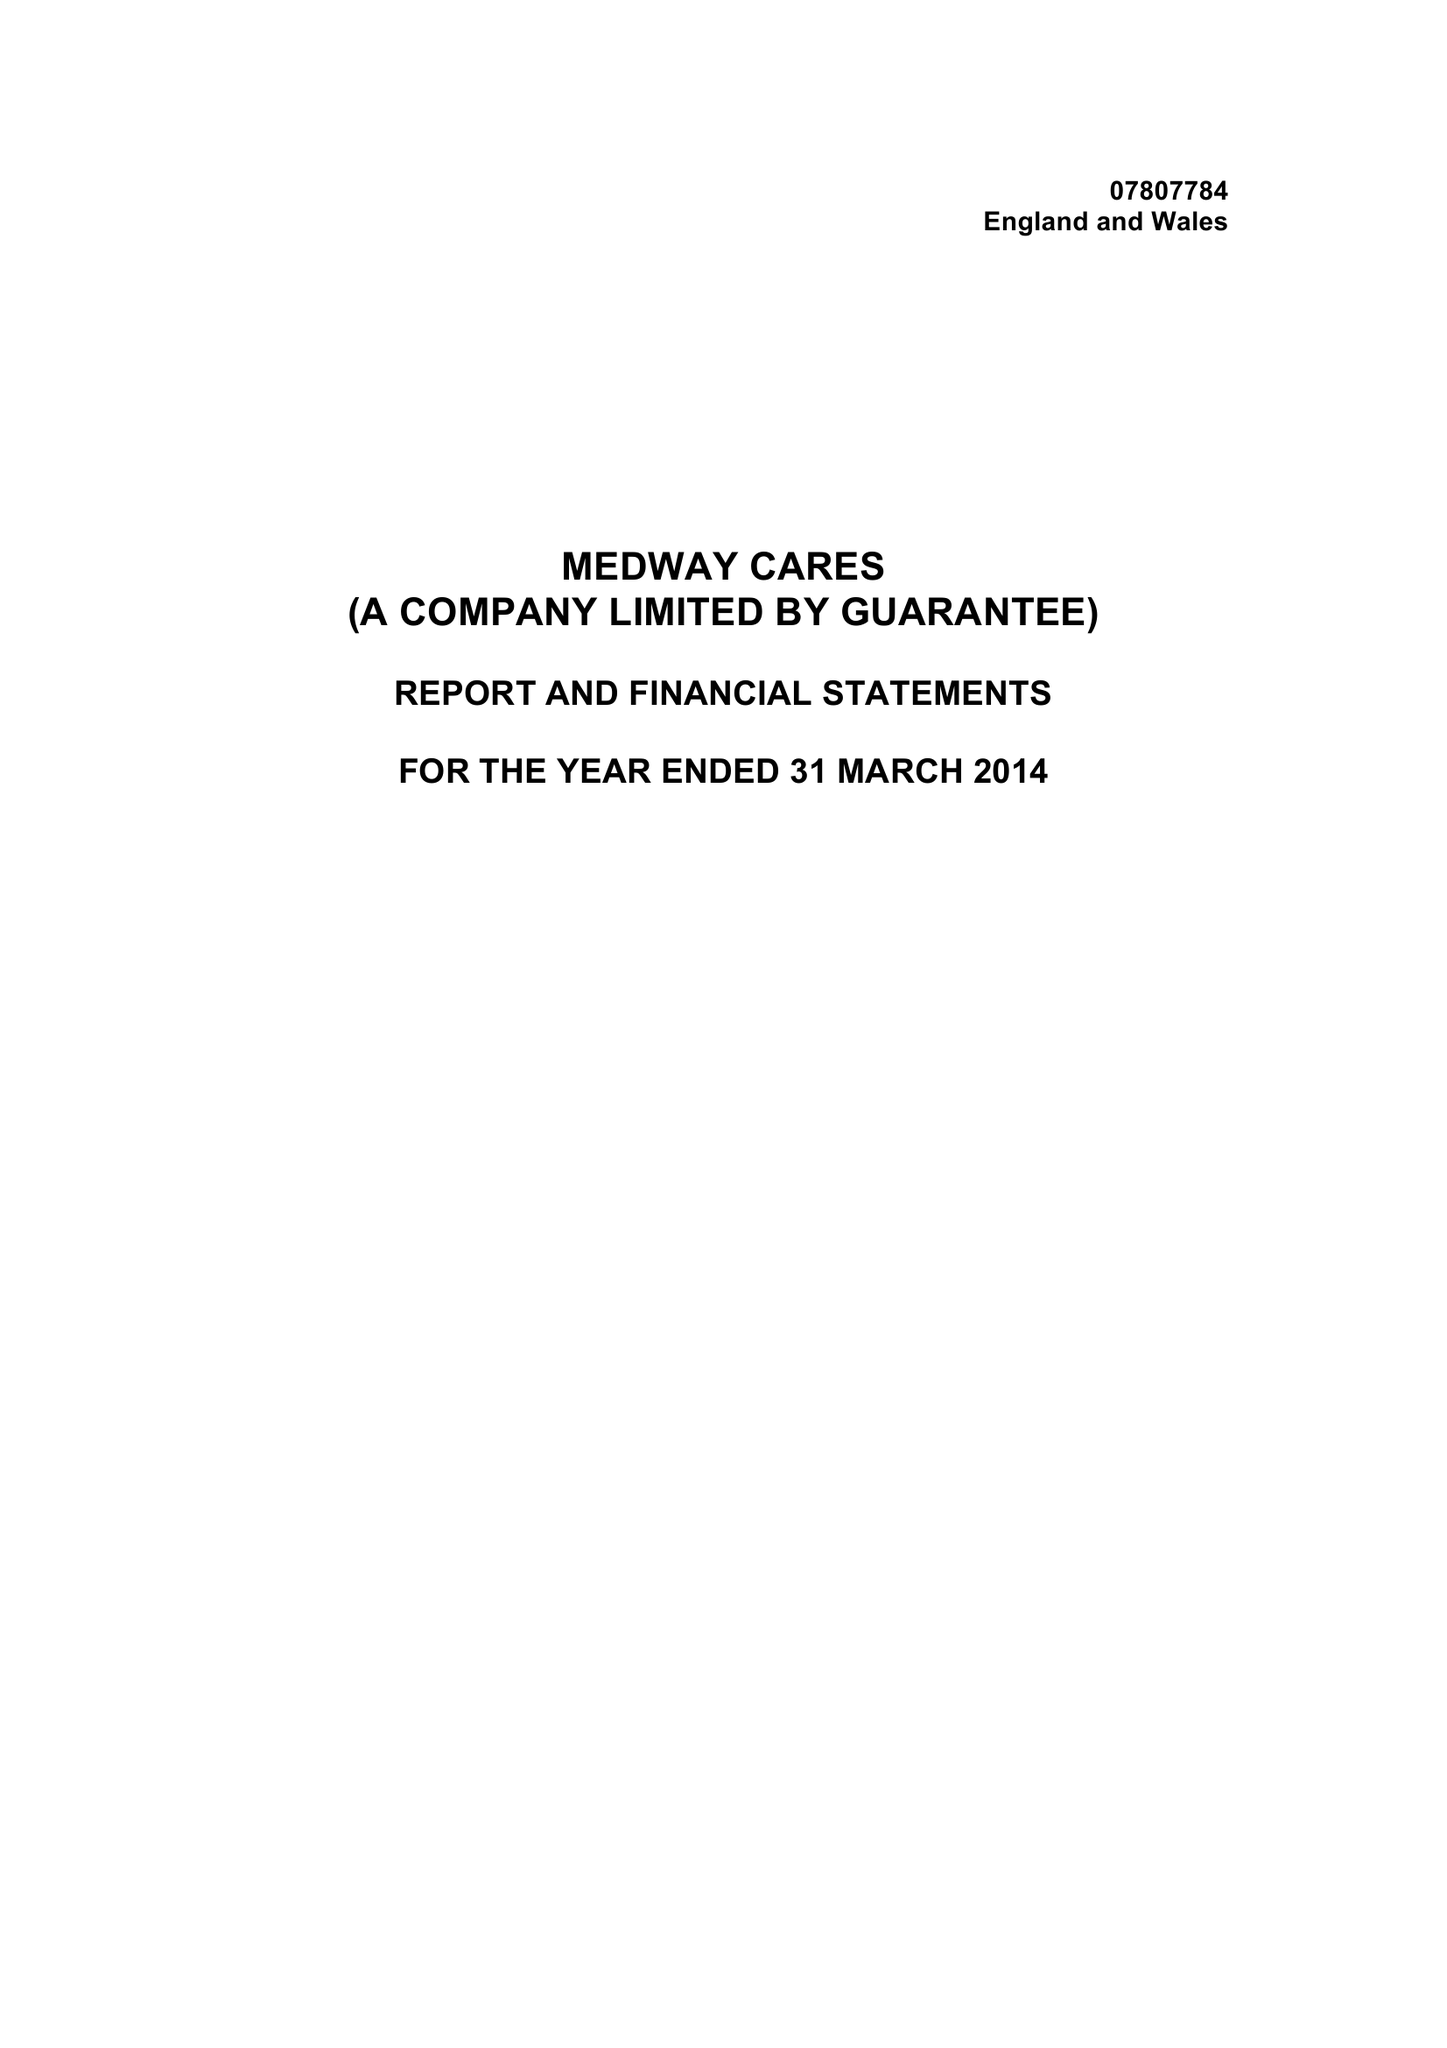What is the value for the address__street_line?
Answer the question using a single word or phrase. BAILEY DRIVE 